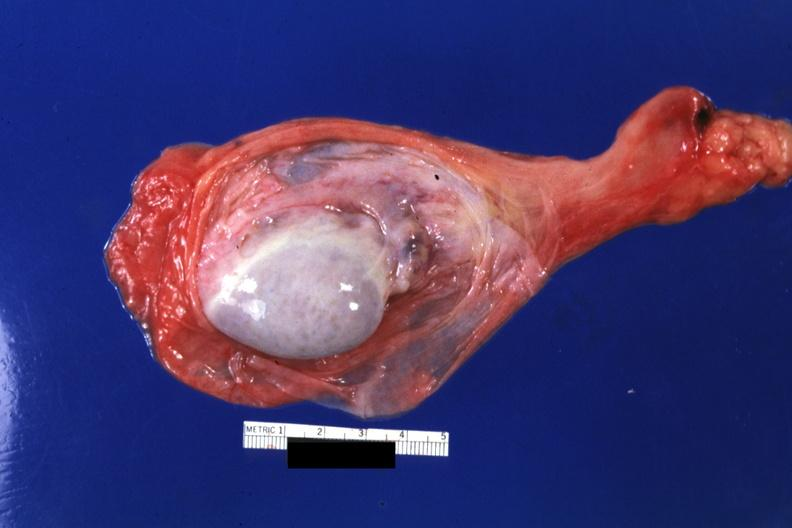what is present?
Answer the question using a single word or phrase. Hydrocele 